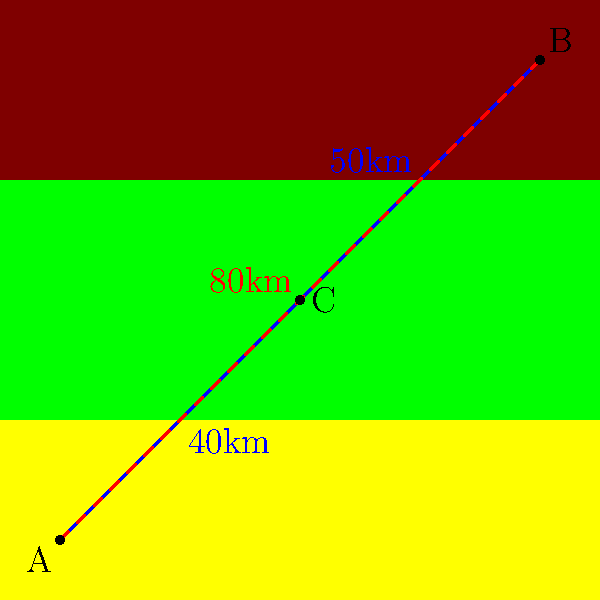You are planning the most efficient route to connect three remote indigenous communities (A, B, and C) across varied terrain. The direct path between A and B (shown in red) is 80km long and crosses difficult mountainous areas. An alternative route through community C (shown in blue) consists of two segments: A to C (40km) and C to B (50km). Which route should be chosen for establishing a road network, and what is the total distance saved by choosing this route? To solve this problem, we need to compare the two possible routes:

1. Direct route (A to B):
   - Distance: 80km
   - Terrain: Crosses difficult mountainous areas

2. Alternative route (A to C to B):
   - Distance: A to C (40km) + C to B (50km) = 90km
   - Terrain: Passes through easier desert and forest areas

Step 1: Calculate the total distance for the alternative route
$$ \text{Alternative route distance} = 40\text{km} + 50\text{km} = 90\text{km} $$

Step 2: Compare the distances
Direct route: 80km
Alternative route: 90km

Step 3: Consider the terrain
Although the alternative route is 10km longer, it avoids the difficult mountainous terrain, which would likely make road construction and maintenance easier and more cost-effective in the long run.

Step 4: Make a decision
Choose the alternative route (A to C to B) due to easier terrain, despite being slightly longer.

Step 5: Calculate the difference in distance
$$ \text{Difference} = \text{Alternative route} - \text{Direct route} = 90\text{km} - 80\text{km} = 10\text{km} $$

The alternative route is 10km longer, so there is no distance saved. However, the benefits of easier terrain outweigh the slight increase in distance.
Answer: Choose A-C-B route; 10km longer but easier terrain. 